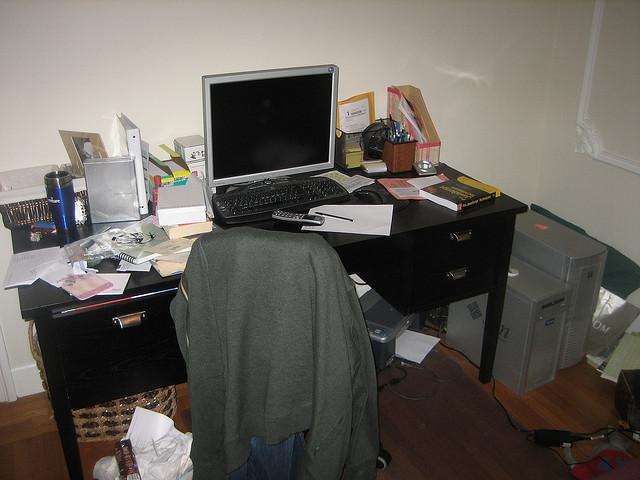What is in the room?

Choices:
A) dog
B) basketball hoop
C) messy desk
D) cat messy desk 